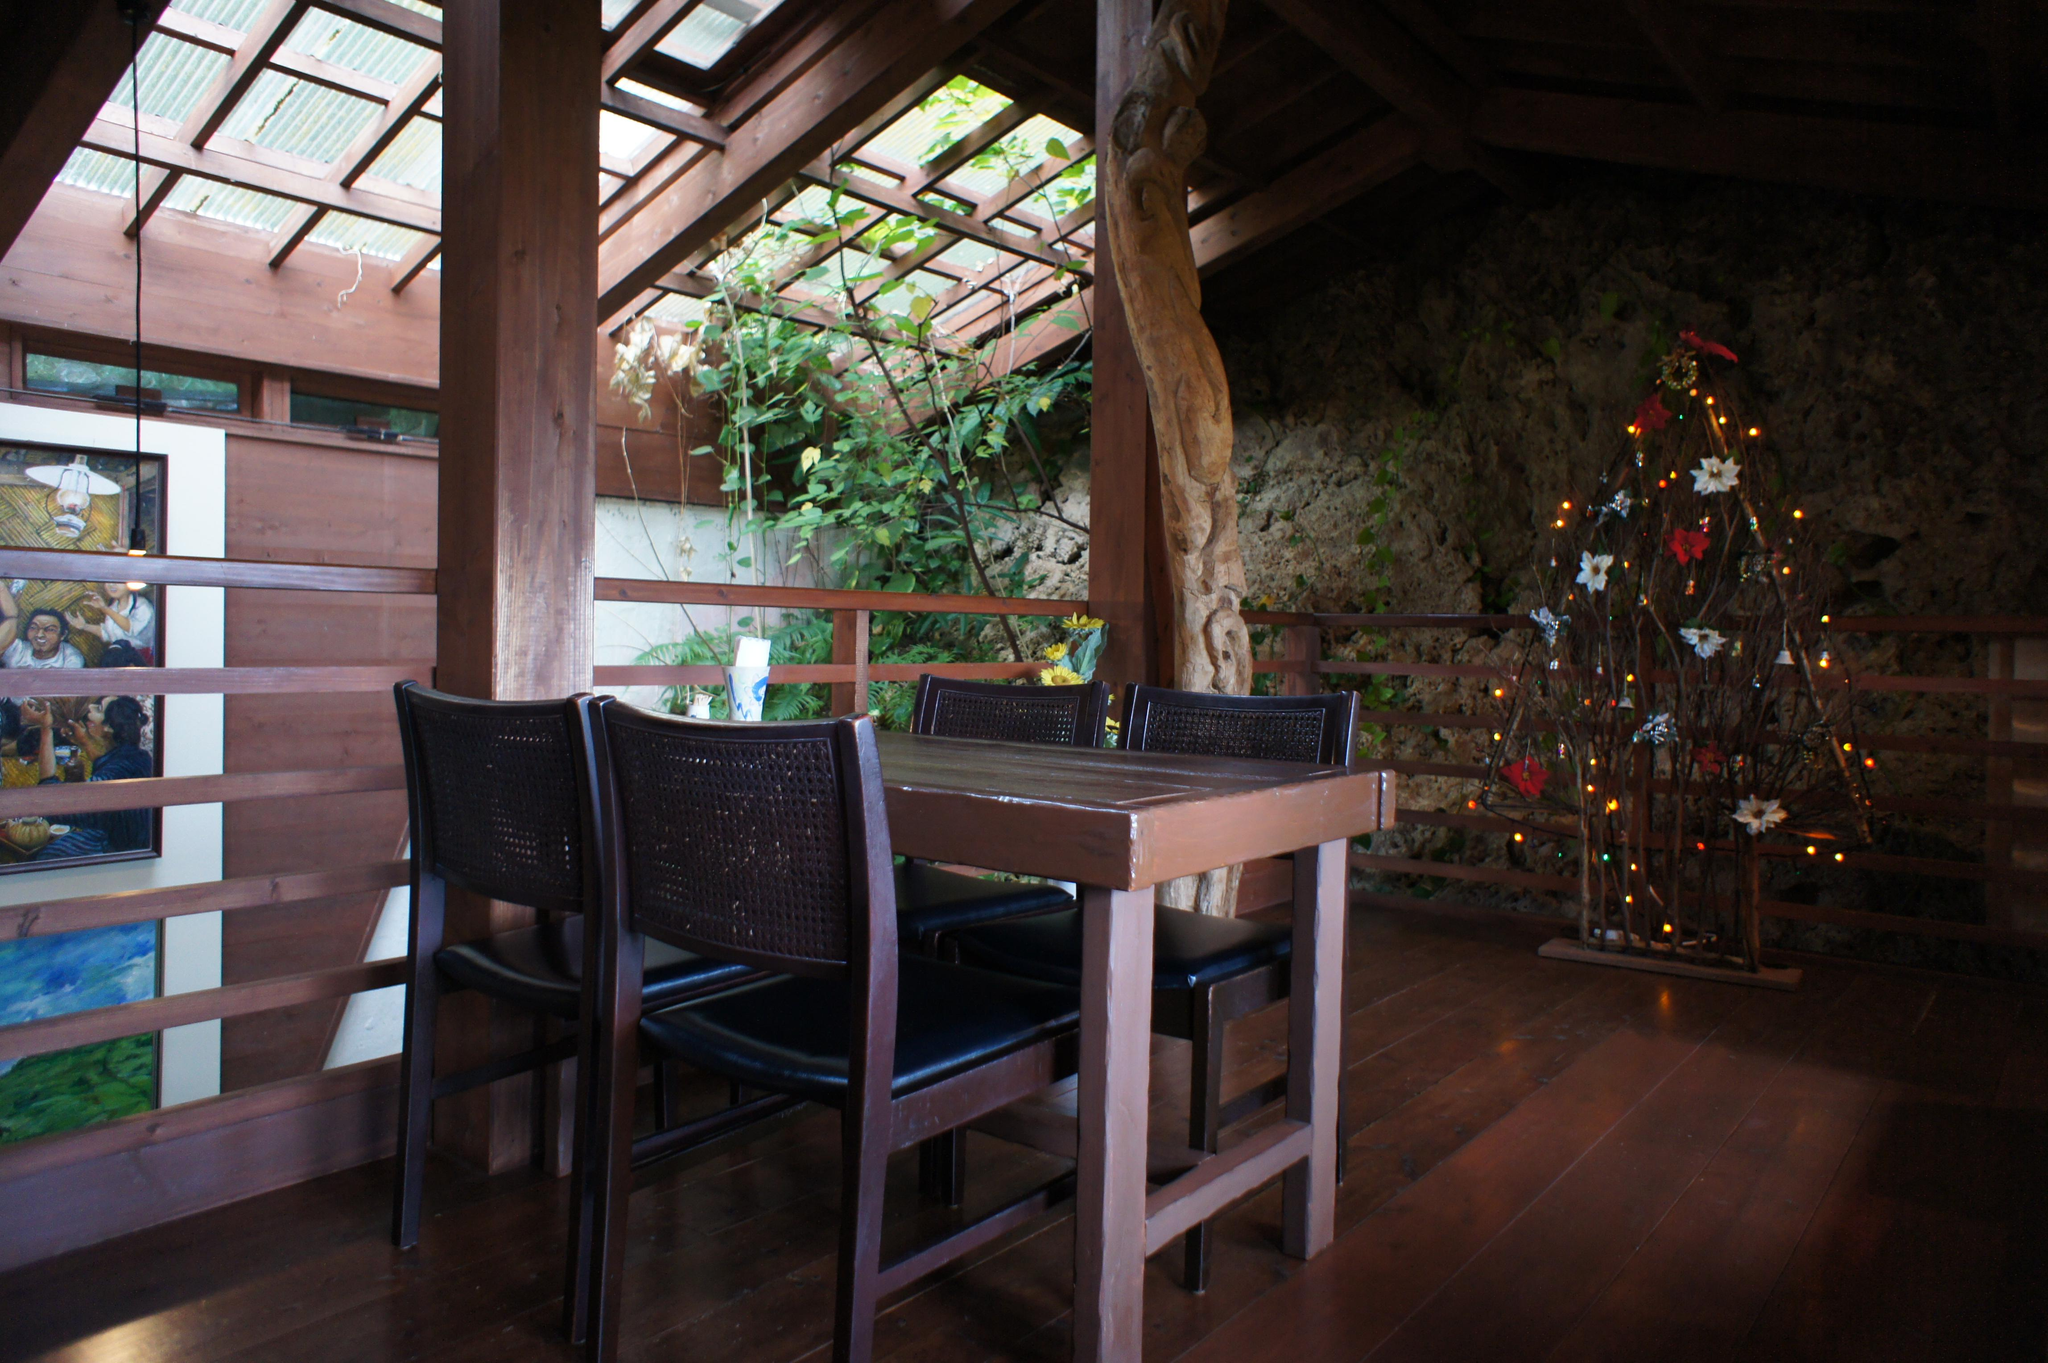What type of structure is visible in the image? There is a house in the image. What piece of furniture can be seen inside the house? There is a table in the image. Are there any seating options visible in the image? Yes, there are chairs in the image. What is hanging on the wall in the image? There is a wall with a photo frame in the image. What type of items are present for decoration in the image? There are decorative items in the image. What type of natural elements can be seen in the image? There are trees in the image. What type of barrier is present in the image? There is a fence in the image. What type of music can be heard playing in the background of the image? There is no music present in the image, as it is a still photograph. 